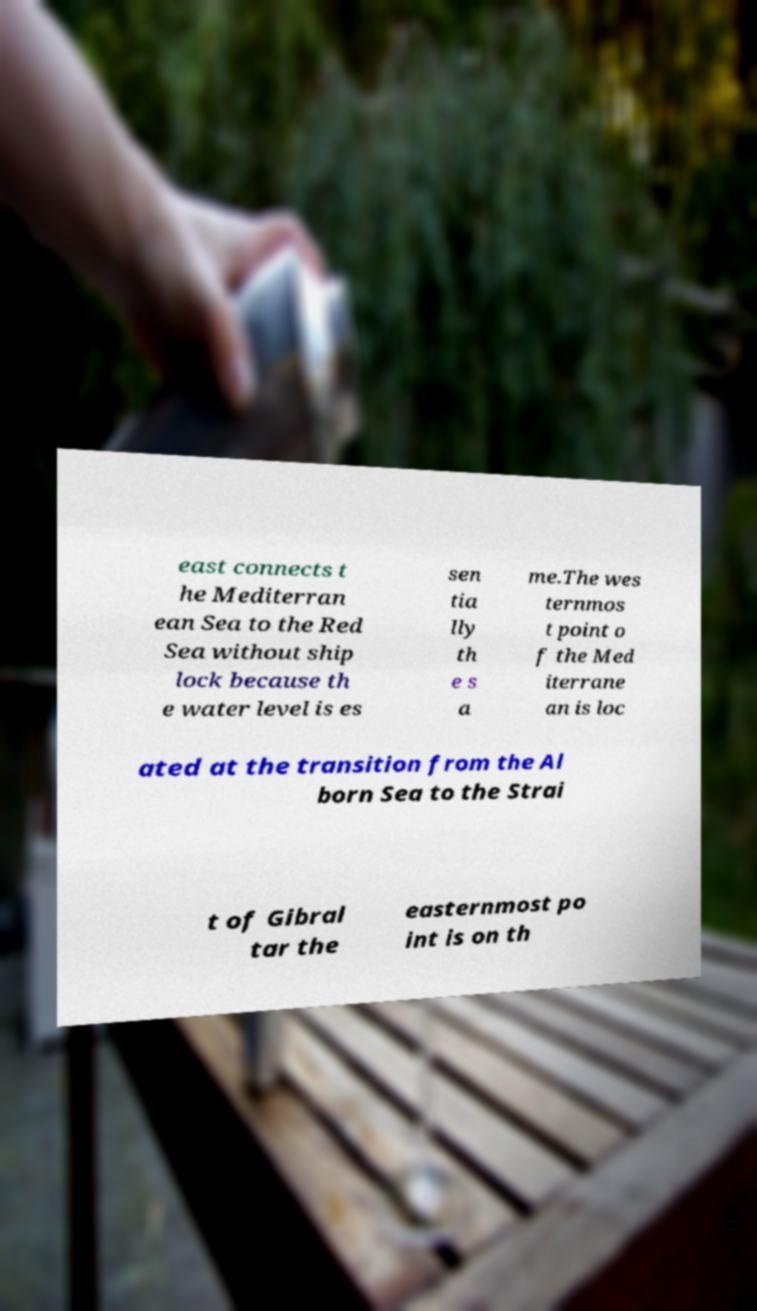There's text embedded in this image that I need extracted. Can you transcribe it verbatim? east connects t he Mediterran ean Sea to the Red Sea without ship lock because th e water level is es sen tia lly th e s a me.The wes ternmos t point o f the Med iterrane an is loc ated at the transition from the Al born Sea to the Strai t of Gibral tar the easternmost po int is on th 